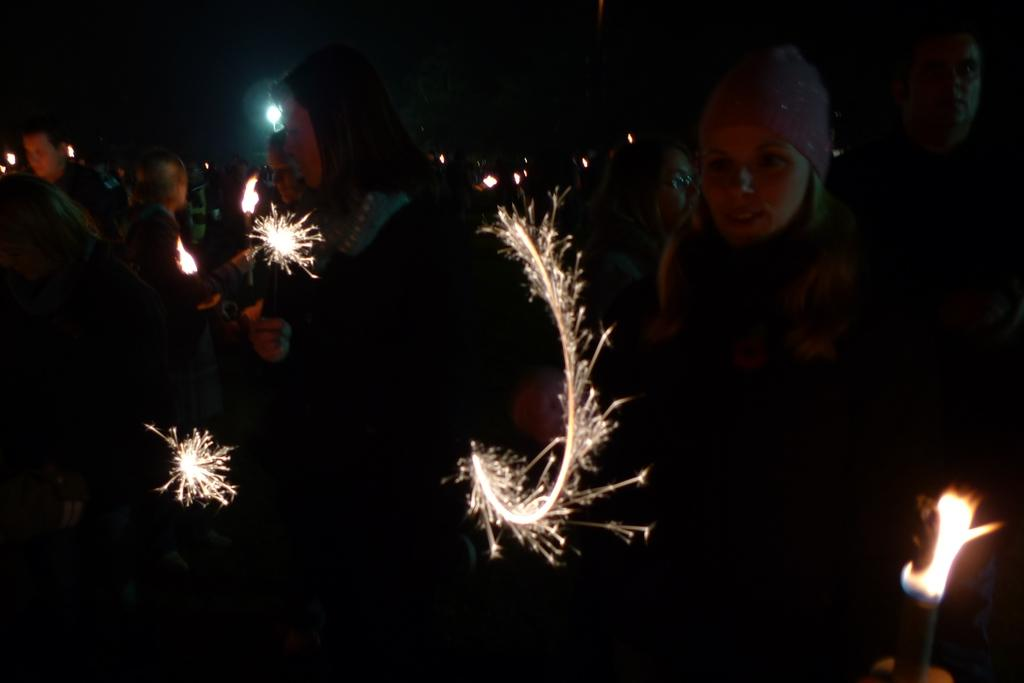What is happening in the image involving the people? Some of the people are holding candles, and some are firing crackers in their hands. What can be observed about the lighting in the image? The background of the image is dark. What type of drain is visible in the image? There is no drain present in the image. How does the loss of the candles affect the people in the image? There is no mention of any loss of candles in the image, and the people are holding candles. 